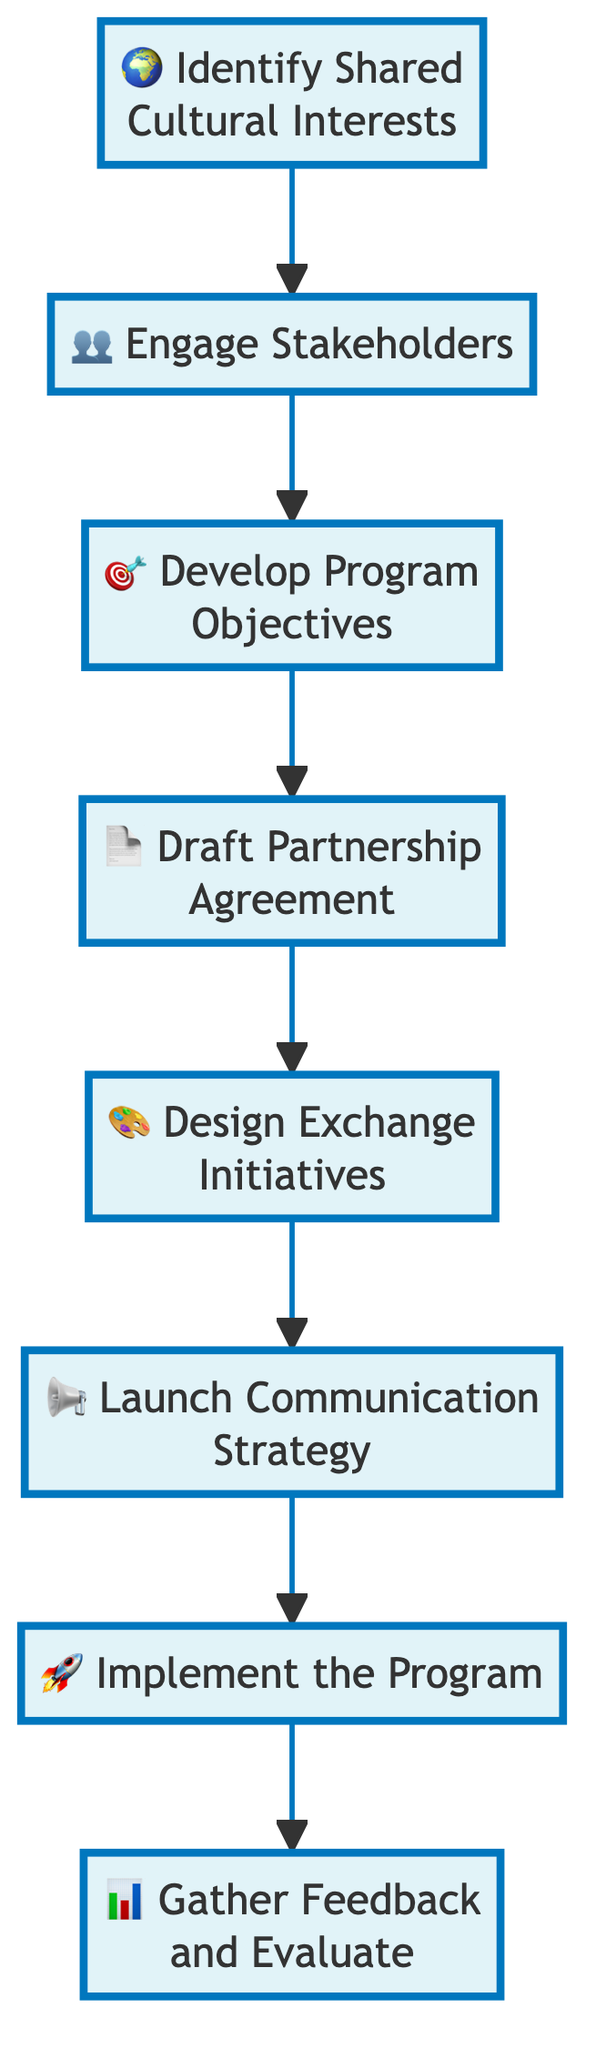What is the first step in the cultural exchange program? The diagram starts with the node labeled "Identify Shared Cultural Interests," which represents the first step in the flow.
Answer: Identify Shared Cultural Interests How many steps are outlined in the flow chart? By counting the nodes listed in the flow chart, there are a total of eight distinct steps that make up the process.
Answer: Eight What step follows "Draft Partnership Agreement"? The flow indicates that after "Draft Partnership Agreement," the next step is "Design Exchange Initiatives," showing the sequential order of the program's steps.
Answer: Design Exchange Initiatives Which stakeholder groups are involved in the step "Engage Stakeholders"? The "Engage Stakeholders" step emphasizes the inclusion of cultural institutions, educational organizations, and local communities from both countries as key stakeholders.
Answer: Cultural institutions, educational organizations, local communities What is the final step in the cultural exchange program? The flow chart concludes with the step marked "Gather Feedback and Evaluate," representing the last action to assess the program’s effectiveness.
Answer: Gather Feedback and Evaluate Which two steps are directly connected before the implementation of the program? Analyzing the flow, "Launch Communication Strategy" is followed by "Implement the Program," indicating the steps that lead directly into the program's execution.
Answer: Launch Communication Strategy and Implement the Program What is the goal of the "Develop Program Objectives" step? The description associated with this step outlines that it involves establishing clear goals for the cultural exchange program, focusing on promoting arts, language, or traditions.
Answer: Establish clear goals What type of strategy is to be launched just before the program implementation? The step entitled "Launch Communication Strategy" suggests that a strategy aimed at promoting the program will be implemented prior to executing the planned initiatives.
Answer: Communication Strategy 